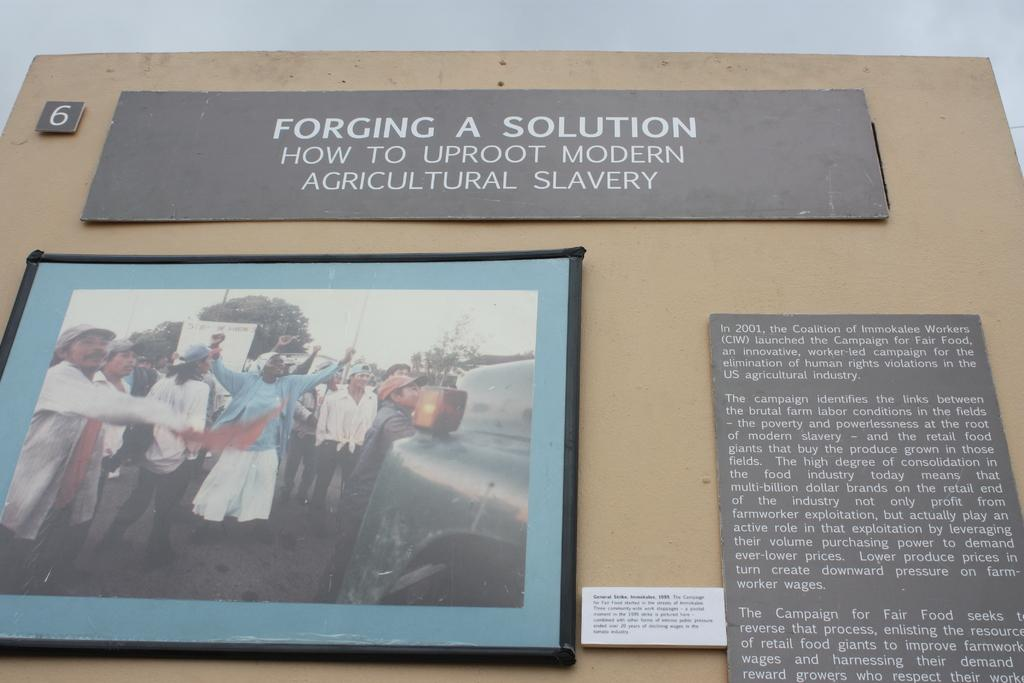<image>
Offer a succinct explanation of the picture presented. the word solution is on the brown surface 